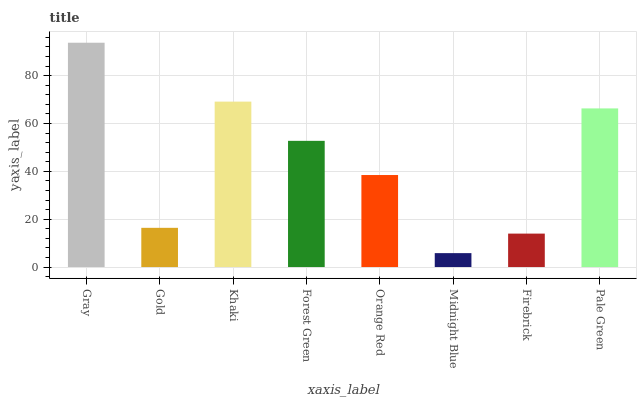Is Midnight Blue the minimum?
Answer yes or no. Yes. Is Gray the maximum?
Answer yes or no. Yes. Is Gold the minimum?
Answer yes or no. No. Is Gold the maximum?
Answer yes or no. No. Is Gray greater than Gold?
Answer yes or no. Yes. Is Gold less than Gray?
Answer yes or no. Yes. Is Gold greater than Gray?
Answer yes or no. No. Is Gray less than Gold?
Answer yes or no. No. Is Forest Green the high median?
Answer yes or no. Yes. Is Orange Red the low median?
Answer yes or no. Yes. Is Khaki the high median?
Answer yes or no. No. Is Gray the low median?
Answer yes or no. No. 